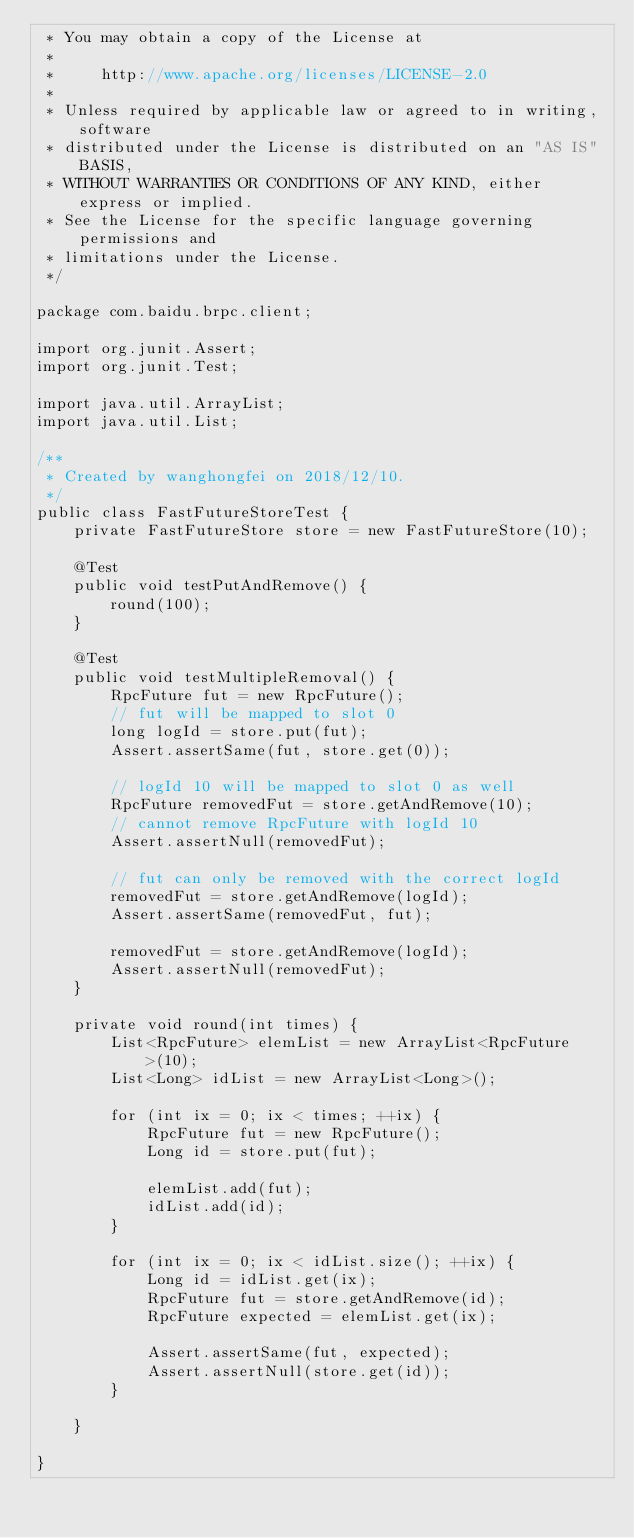<code> <loc_0><loc_0><loc_500><loc_500><_Java_> * You may obtain a copy of the License at
 *
 *     http://www.apache.org/licenses/LICENSE-2.0
 *
 * Unless required by applicable law or agreed to in writing, software
 * distributed under the License is distributed on an "AS IS" BASIS,
 * WITHOUT WARRANTIES OR CONDITIONS OF ANY KIND, either express or implied.
 * See the License for the specific language governing permissions and
 * limitations under the License.
 */

package com.baidu.brpc.client;

import org.junit.Assert;
import org.junit.Test;

import java.util.ArrayList;
import java.util.List;

/**
 * Created by wanghongfei on 2018/12/10.
 */
public class FastFutureStoreTest {
    private FastFutureStore store = new FastFutureStore(10);

    @Test
    public void testPutAndRemove() {
        round(100);
    }

    @Test
    public void testMultipleRemoval() {
        RpcFuture fut = new RpcFuture();
        // fut will be mapped to slot 0
        long logId = store.put(fut);
        Assert.assertSame(fut, store.get(0));

        // logId 10 will be mapped to slot 0 as well
        RpcFuture removedFut = store.getAndRemove(10);
        // cannot remove RpcFuture with logId 10
        Assert.assertNull(removedFut);

        // fut can only be removed with the correct logId
        removedFut = store.getAndRemove(logId);
        Assert.assertSame(removedFut, fut);

        removedFut = store.getAndRemove(logId);
        Assert.assertNull(removedFut);
    }

    private void round(int times) {
        List<RpcFuture> elemList = new ArrayList<RpcFuture>(10);
        List<Long> idList = new ArrayList<Long>();

        for (int ix = 0; ix < times; ++ix) {
            RpcFuture fut = new RpcFuture();
            Long id = store.put(fut);

            elemList.add(fut);
            idList.add(id);
        }

        for (int ix = 0; ix < idList.size(); ++ix) {
            Long id = idList.get(ix);
            RpcFuture fut = store.getAndRemove(id);
            RpcFuture expected = elemList.get(ix);

            Assert.assertSame(fut, expected);
            Assert.assertNull(store.get(id));
        }

    }

}
</code> 